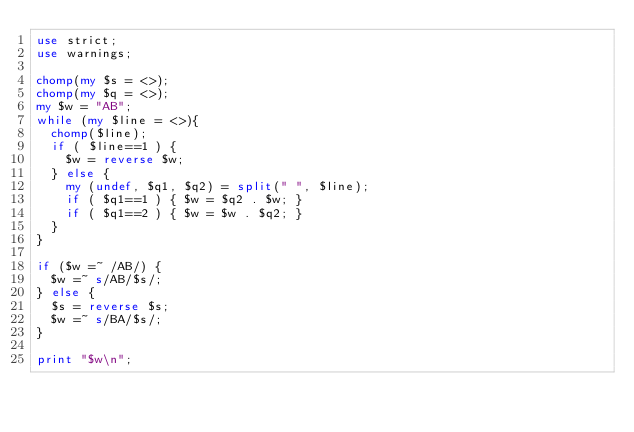Convert code to text. <code><loc_0><loc_0><loc_500><loc_500><_Perl_>use strict;
use warnings;

chomp(my $s = <>);
chomp(my $q = <>);
my $w = "AB";
while (my $line = <>){
  chomp($line);
  if ( $line==1 ) {
    $w = reverse $w;
  } else {
    my (undef, $q1, $q2) = split(" ", $line);
    if ( $q1==1 ) { $w = $q2 . $w; }
    if ( $q1==2 ) { $w = $w . $q2; }
  }
}

if ($w =~ /AB/) {
  $w =~ s/AB/$s/;
} else {
  $s = reverse $s;
  $w =~ s/BA/$s/;
}

print "$w\n";
</code> 